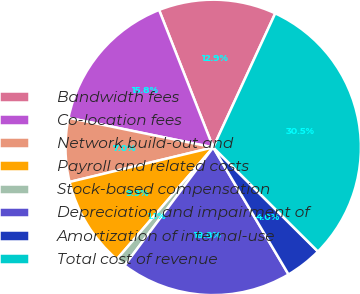Convert chart. <chart><loc_0><loc_0><loc_500><loc_500><pie_chart><fcel>Bandwidth fees<fcel>Co-location fees<fcel>Network build-out and<fcel>Payroll and related costs<fcel>Stock-based compensation<fcel>Depreciation and impairment of<fcel>Amortization of internal-use<fcel>Total cost of revenue<nl><fcel>12.87%<fcel>15.82%<fcel>6.97%<fcel>9.92%<fcel>1.08%<fcel>18.76%<fcel>4.03%<fcel>30.55%<nl></chart> 